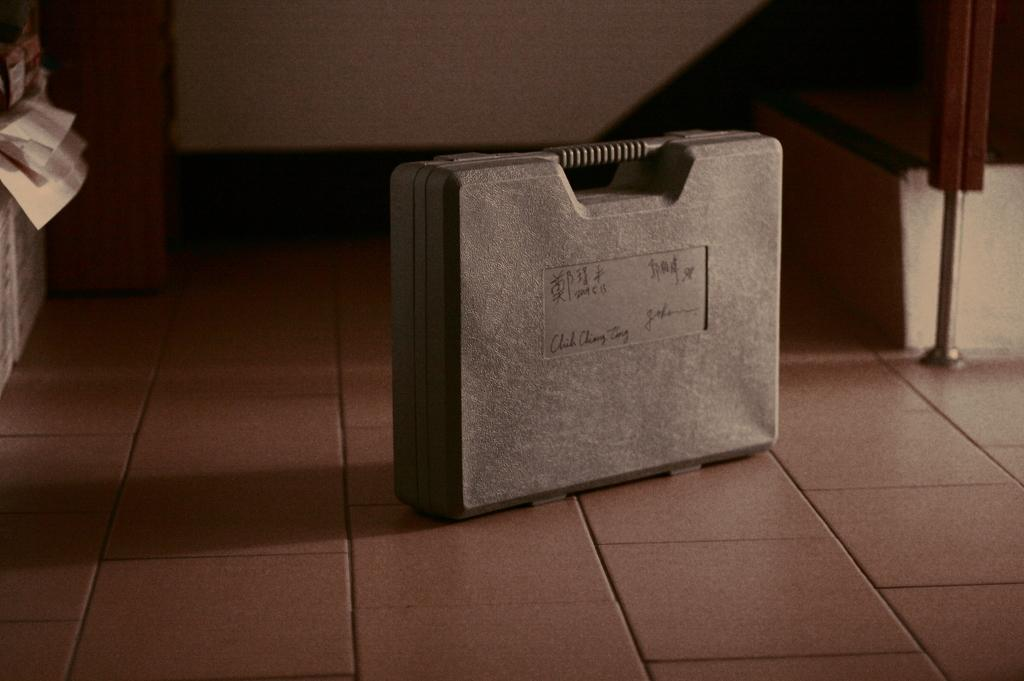What object is placed on the floor in the image? There is a suitcase on the floor. What type of zipper can be seen on the kitty in the image? There is no kitty present in the image, and therefore no zipper can be observed. 